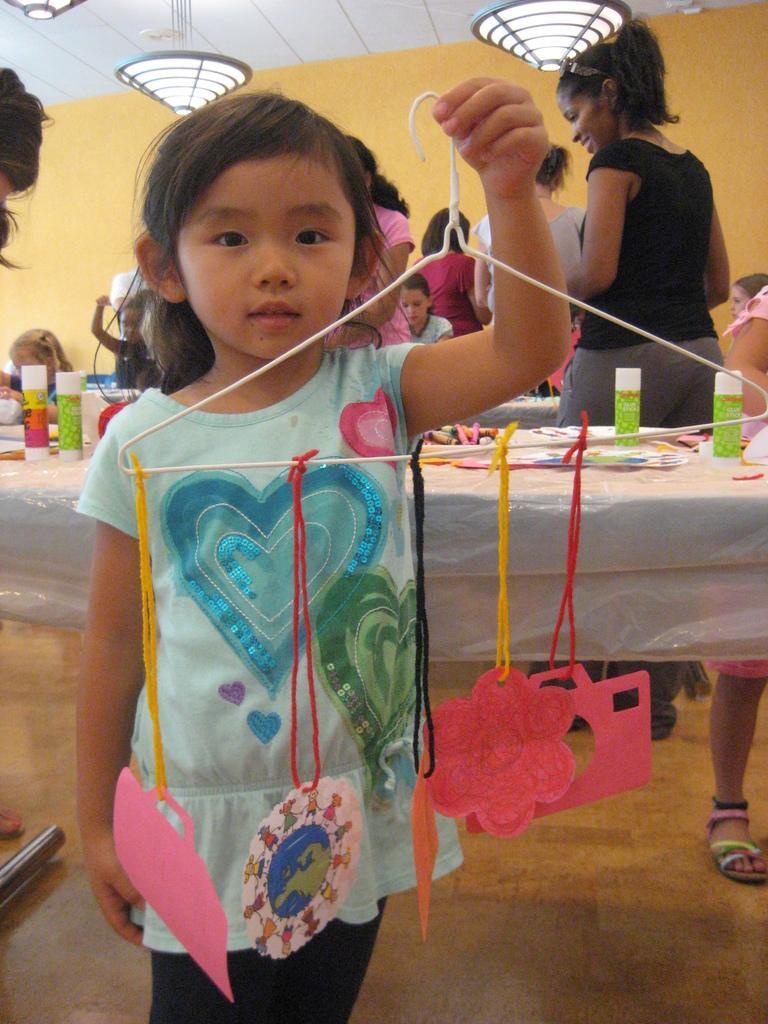Describe this image in one or two sentences. In this image we can see a girl holding an object and standing. In the background we can see some women and also the kids. We can also see the tables which are covered with a cover and on the table we can see the bottles, papers. At the top we can see the lights and also the ceiling. Image also consists of a rod on the floor. We can also see the plain wall. 